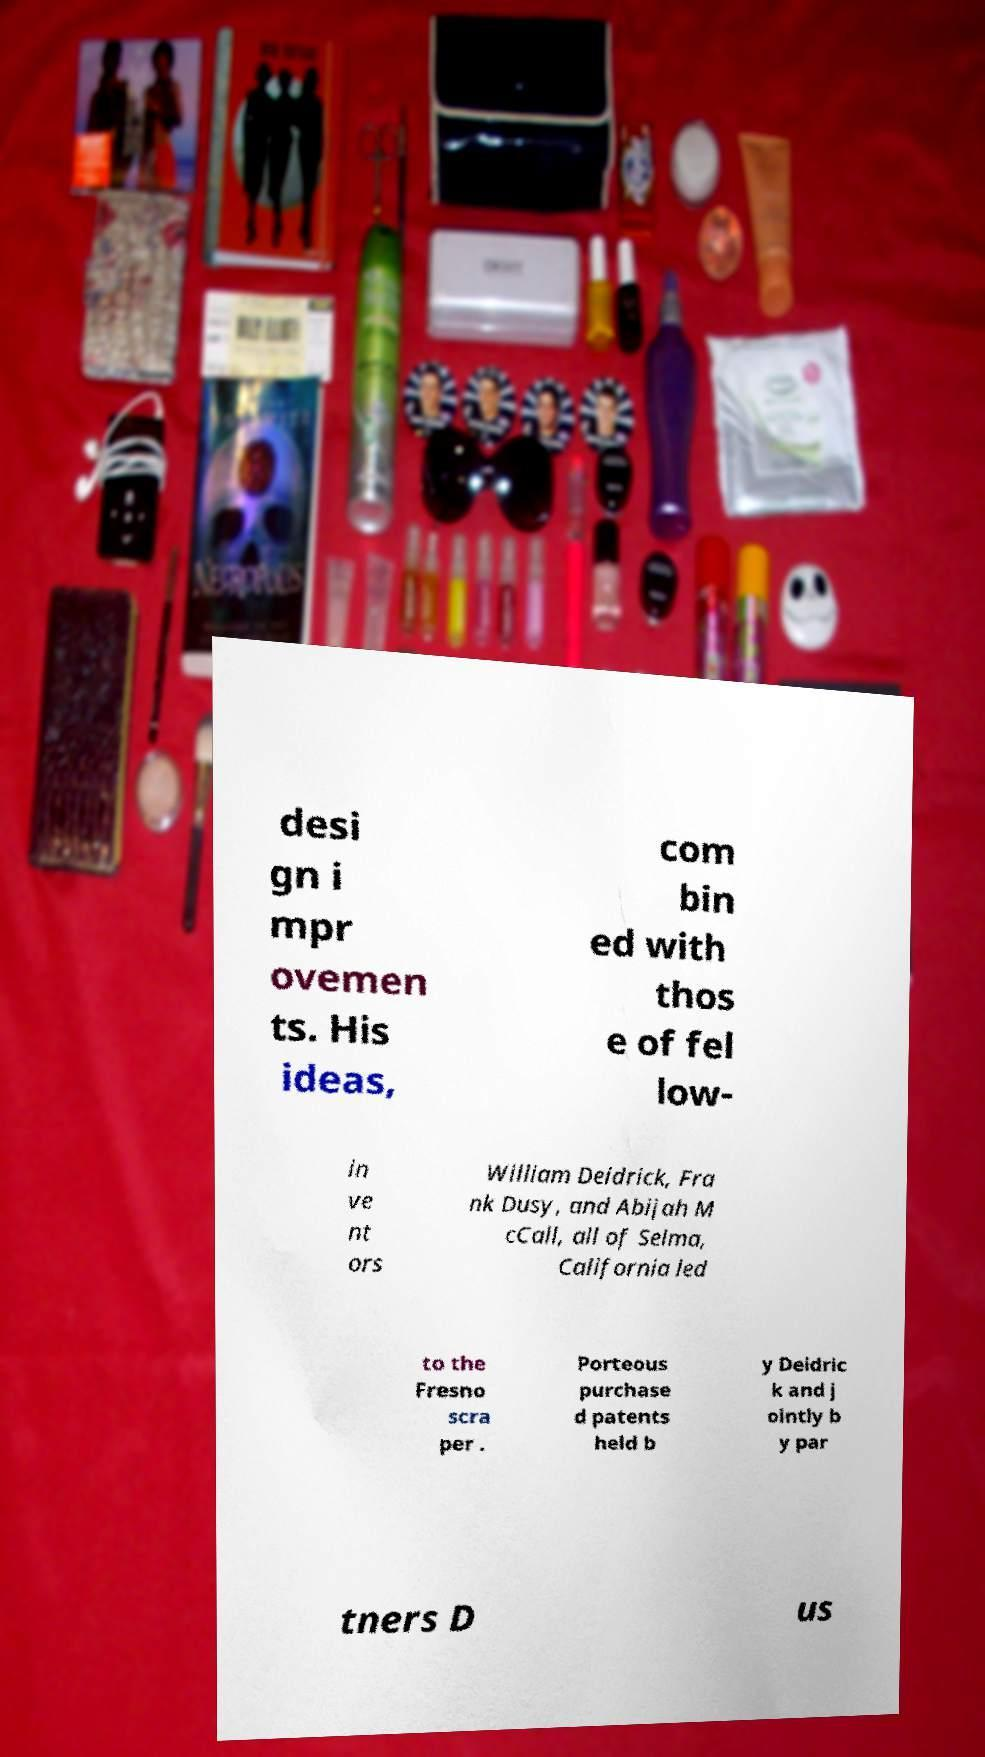What messages or text are displayed in this image? I need them in a readable, typed format. desi gn i mpr ovemen ts. His ideas, com bin ed with thos e of fel low- in ve nt ors William Deidrick, Fra nk Dusy, and Abijah M cCall, all of Selma, California led to the Fresno scra per . Porteous purchase d patents held b y Deidric k and j ointly b y par tners D us 